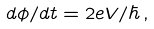<formula> <loc_0><loc_0><loc_500><loc_500>d \phi / d t = 2 e V / \hbar { \, } ,</formula> 